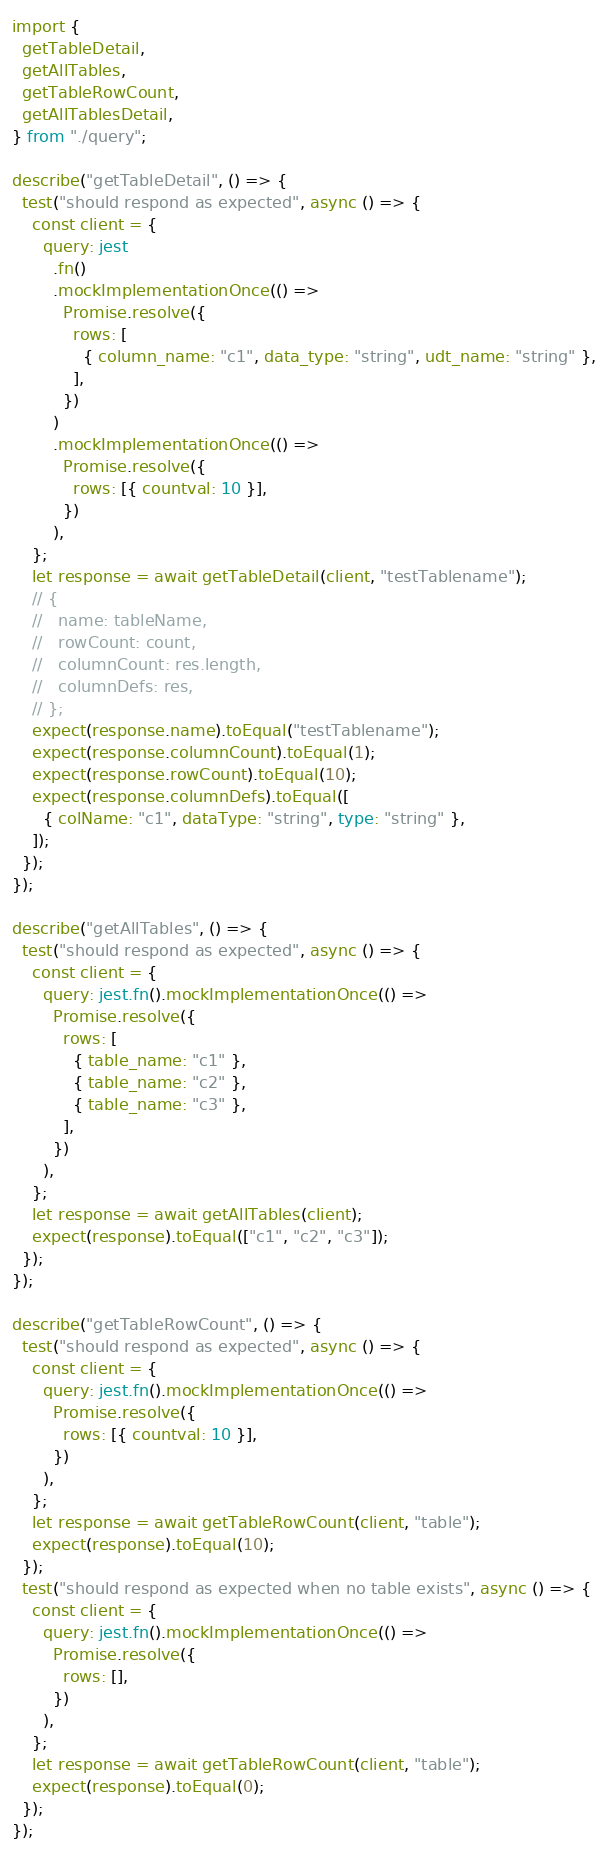Convert code to text. <code><loc_0><loc_0><loc_500><loc_500><_TypeScript_>import {
  getTableDetail,
  getAllTables,
  getTableRowCount,
  getAllTablesDetail,
} from "./query";

describe("getTableDetail", () => {
  test("should respond as expected", async () => {
    const client = {
      query: jest
        .fn()
        .mockImplementationOnce(() =>
          Promise.resolve({
            rows: [
              { column_name: "c1", data_type: "string", udt_name: "string" },
            ],
          })
        )
        .mockImplementationOnce(() =>
          Promise.resolve({
            rows: [{ countval: 10 }],
          })
        ),
    };
    let response = await getTableDetail(client, "testTablename");
    // {
    //   name: tableName,
    //   rowCount: count,
    //   columnCount: res.length,
    //   columnDefs: res,
    // };
    expect(response.name).toEqual("testTablename");
    expect(response.columnCount).toEqual(1);
    expect(response.rowCount).toEqual(10);
    expect(response.columnDefs).toEqual([
      { colName: "c1", dataType: "string", type: "string" },
    ]);
  });
});

describe("getAllTables", () => {
  test("should respond as expected", async () => {
    const client = {
      query: jest.fn().mockImplementationOnce(() =>
        Promise.resolve({
          rows: [
            { table_name: "c1" },
            { table_name: "c2" },
            { table_name: "c3" },
          ],
        })
      ),
    };
    let response = await getAllTables(client);
    expect(response).toEqual(["c1", "c2", "c3"]);
  });
});

describe("getTableRowCount", () => {
  test("should respond as expected", async () => {
    const client = {
      query: jest.fn().mockImplementationOnce(() =>
        Promise.resolve({
          rows: [{ countval: 10 }],
        })
      ),
    };
    let response = await getTableRowCount(client, "table");
    expect(response).toEqual(10);
  });
  test("should respond as expected when no table exists", async () => {
    const client = {
      query: jest.fn().mockImplementationOnce(() =>
        Promise.resolve({
          rows: [],
        })
      ),
    };
    let response = await getTableRowCount(client, "table");
    expect(response).toEqual(0);
  });
});
</code> 